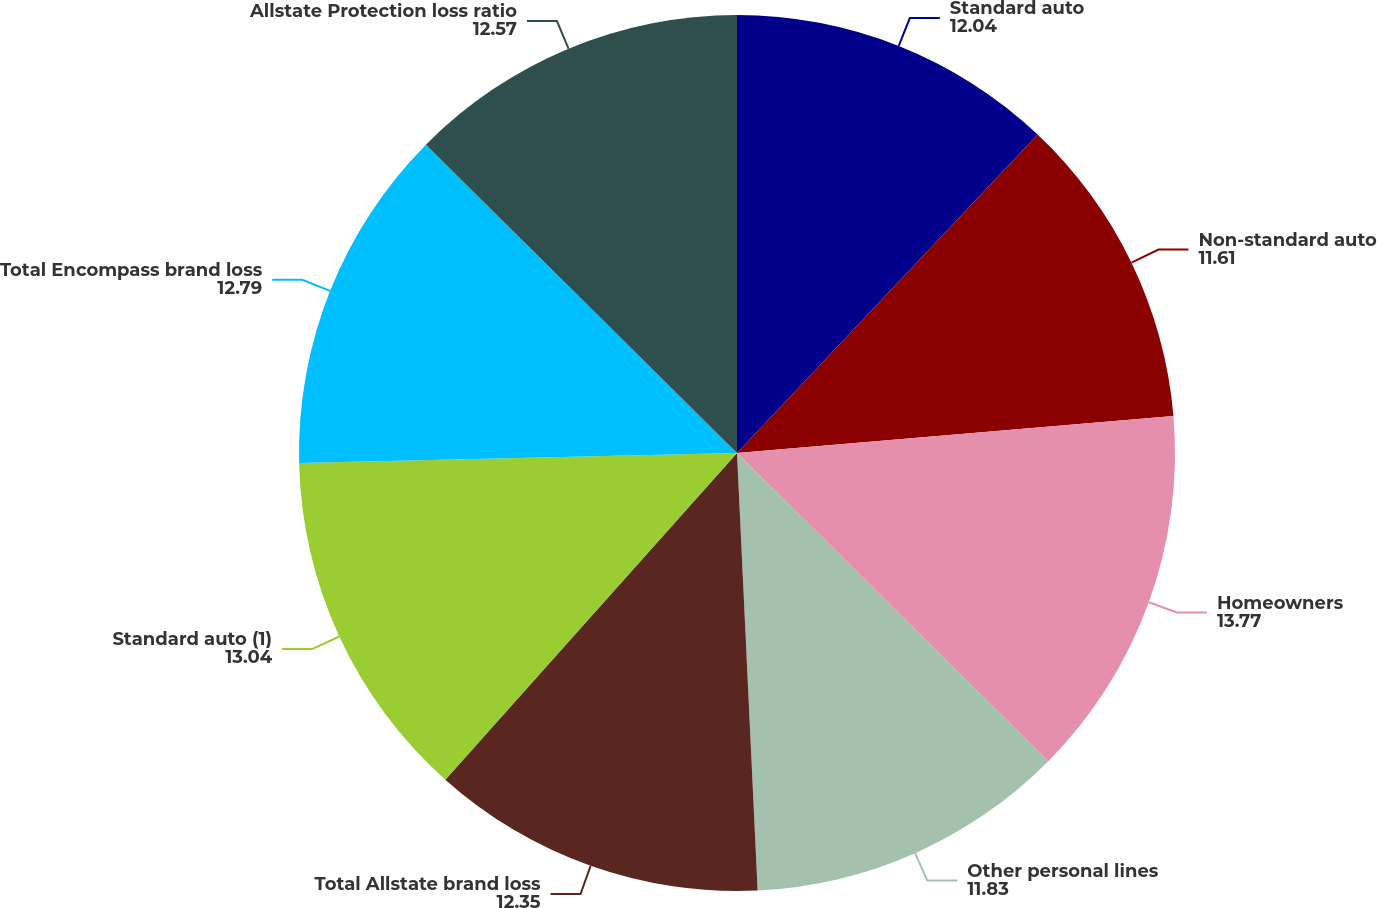<chart> <loc_0><loc_0><loc_500><loc_500><pie_chart><fcel>Standard auto<fcel>Non-standard auto<fcel>Homeowners<fcel>Other personal lines<fcel>Total Allstate brand loss<fcel>Standard auto (1)<fcel>Total Encompass brand loss<fcel>Allstate Protection loss ratio<nl><fcel>12.04%<fcel>11.61%<fcel>13.77%<fcel>11.83%<fcel>12.35%<fcel>13.04%<fcel>12.79%<fcel>12.57%<nl></chart> 